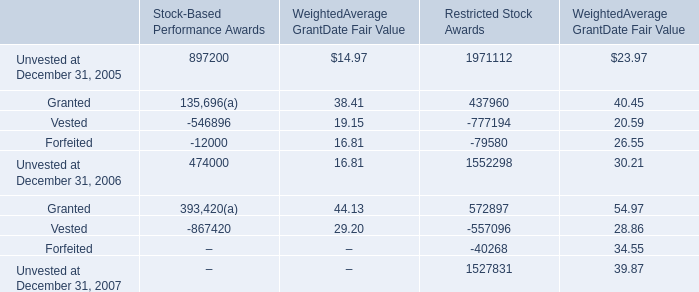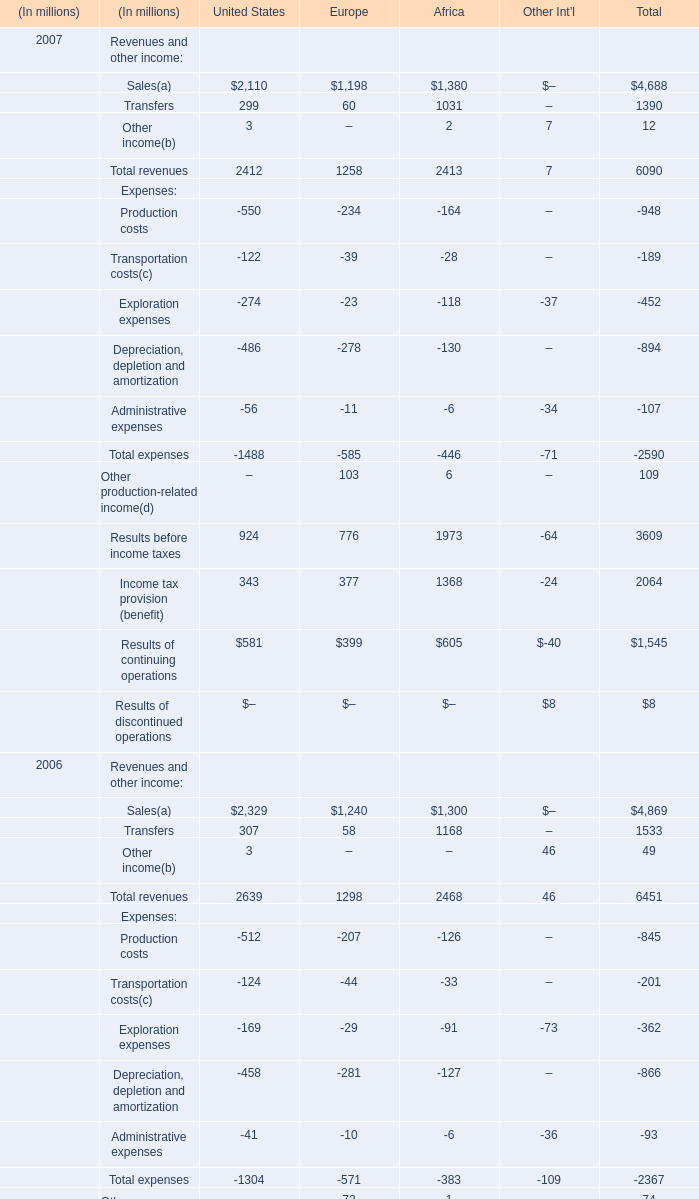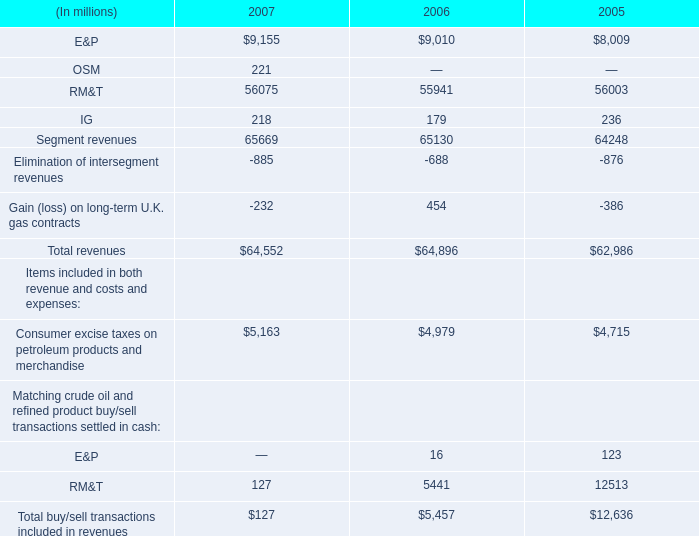The amount of Restricted Stock Awards for Unvested at December 31,what year ranks first? 
Answer: 2005. 